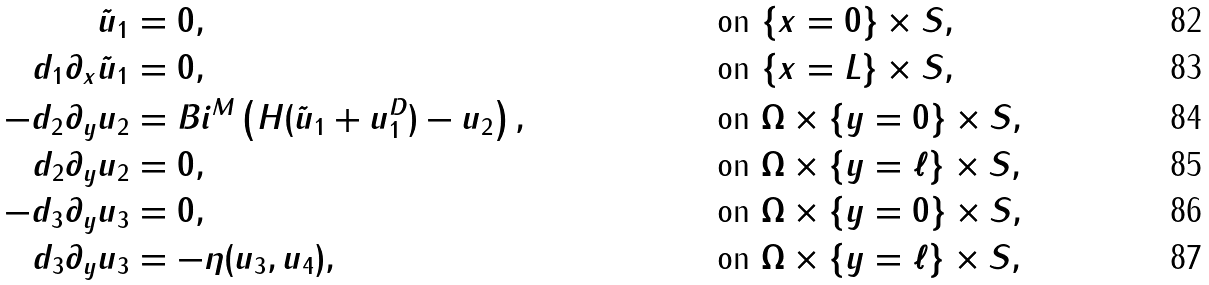<formula> <loc_0><loc_0><loc_500><loc_500>\tilde { u } _ { 1 } & = 0 , & & \text { on } \{ x = 0 \} \times S , \\ d _ { 1 } \partial _ { x } \tilde { u } _ { 1 } & = 0 , & & \text { on } \{ x = L \} \times S , \\ - d _ { 2 } \partial _ { y } u _ { 2 } & = B i ^ { M } \left ( H ( \tilde { u } _ { 1 } + u _ { 1 } ^ { D } ) - u _ { 2 } \right ) , & & \text { on } \Omega \times \{ y = 0 \} \times S , \\ d _ { 2 } \partial _ { y } u _ { 2 } & = 0 , & & \text { on } \Omega \times \{ y = \ell \} \times S , \\ - d _ { 3 } \partial _ { y } u _ { 3 } & = 0 , & & \text { on } \Omega \times \{ y = 0 \} \times S , \\ d _ { 3 } \partial _ { y } u _ { 3 } & = - \eta ( u _ { 3 } , u _ { 4 } ) , & & \text { on } \Omega \times \{ y = \ell \} \times S ,</formula> 